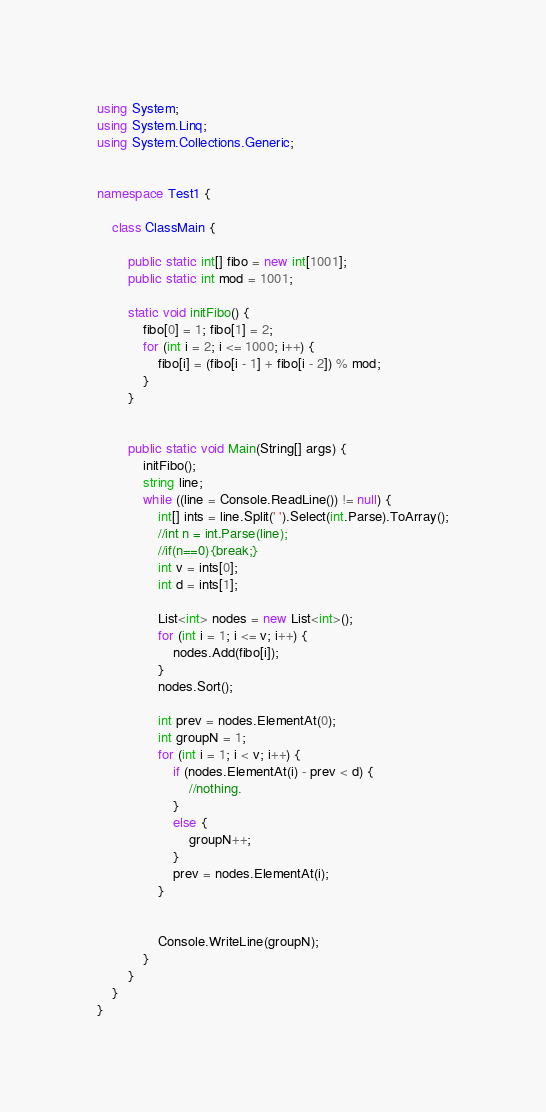<code> <loc_0><loc_0><loc_500><loc_500><_C#_>using System;
using System.Linq;
using System.Collections.Generic;


namespace Test1 {

    class ClassMain {

        public static int[] fibo = new int[1001];
        public static int mod = 1001;

        static void initFibo() {
            fibo[0] = 1; fibo[1] = 2;
            for (int i = 2; i <= 1000; i++) {
                fibo[i] = (fibo[i - 1] + fibo[i - 2]) % mod;
            }
        }


        public static void Main(String[] args) {
            initFibo();
            string line;
            while ((line = Console.ReadLine()) != null) {
                int[] ints = line.Split(' ').Select(int.Parse).ToArray();
                //int n = int.Parse(line);
                //if(n==0){break;}
                int v = ints[0];
                int d = ints[1];

                List<int> nodes = new List<int>();
                for (int i = 1; i <= v; i++) {
                    nodes.Add(fibo[i]);
                }
                nodes.Sort();

                int prev = nodes.ElementAt(0);
                int groupN = 1;
                for (int i = 1; i < v; i++) {
                    if (nodes.ElementAt(i) - prev < d) {
                        //nothing.
                    }
                    else {
                        groupN++;
                    }
                    prev = nodes.ElementAt(i);
                }


                Console.WriteLine(groupN);
            }   
        }   
    }
}</code> 